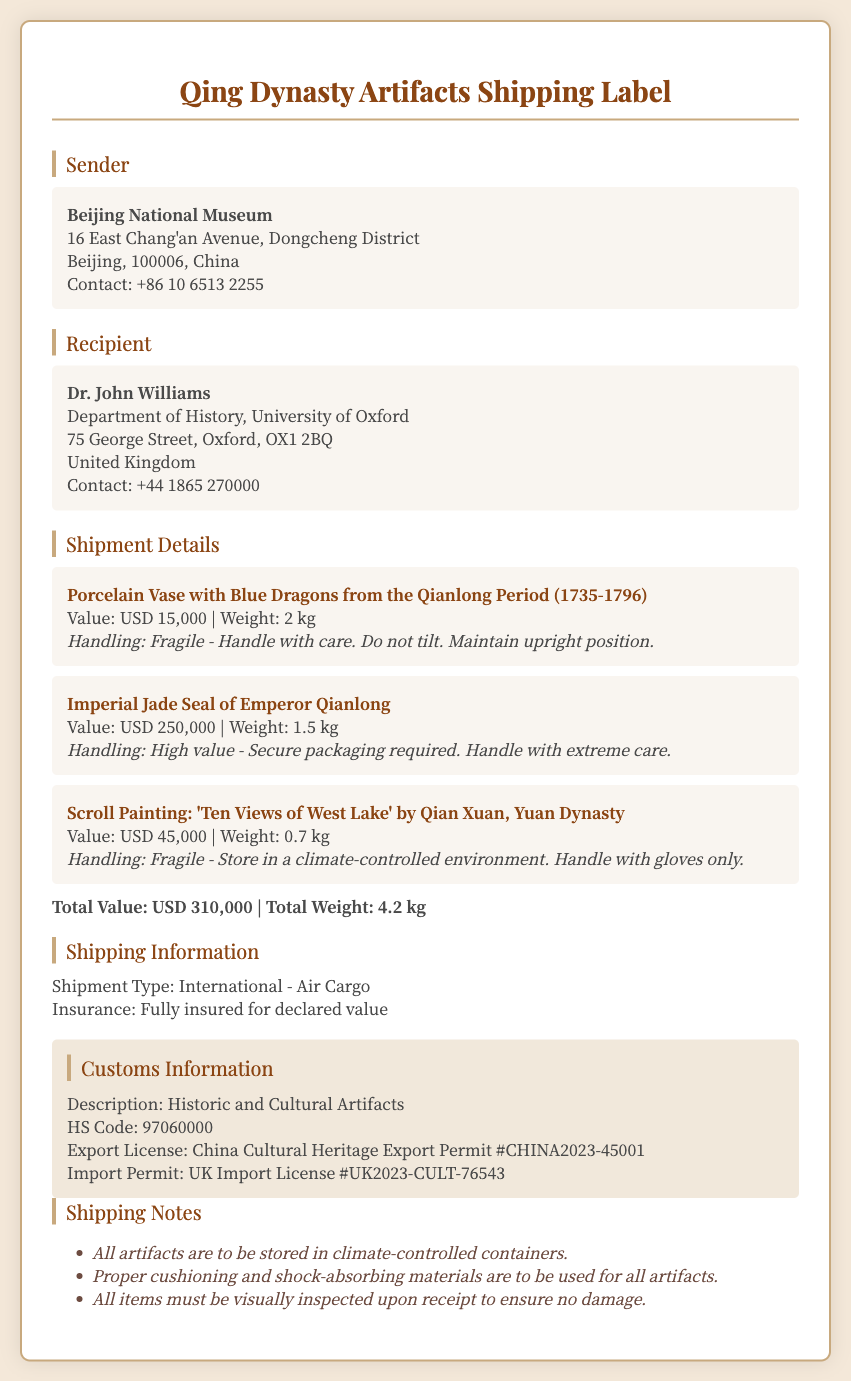What is the sender's name? The sender's name is listed in the address section of the document.
Answer: Beijing National Museum What is the weight of the porcelain vase? The weight of the porcelain vase can be found in its specific item description.
Answer: 2 kg What is the value of the Imperial Jade Seal? The value of the Imperial Jade Seal is stated in the shipment details section.
Answer: USD 250,000 What is the shipping type? The shipping type is mentioned in the shipping information area of the document.
Answer: International - Air Cargo What is the import permit number? The import permit number is provided in the customs information section.
Answer: UK2023-CULT-76543 What is the total weight of all artifacts? The total weight is calculated by adding the weights of all items and is stated in the shipping details.
Answer: 4.2 kg What is the handling instruction for the scroll painting? The handling instruction for the scroll painting is included in its respective item description.
Answer: Handle with gloves only What does HS Code stand for? HS Code refers to a specific classification used for customs purposes, as mentioned in the customs information.
Answer: 97060000 What is the contact number for the recipient? The contact number for the recipient is provided in the recipient's address section.
Answer: +44 1865 270000 